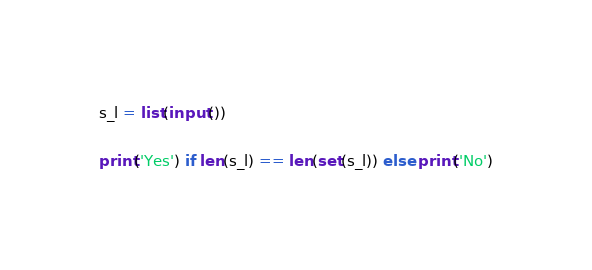<code> <loc_0><loc_0><loc_500><loc_500><_Python_>s_l = list(input())

print('Yes') if len(s_l) == len(set(s_l)) else print('No')</code> 